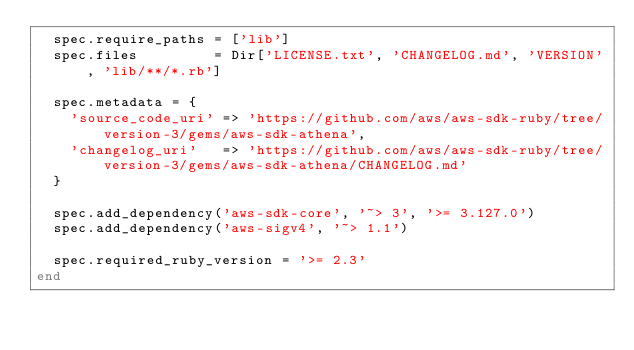<code> <loc_0><loc_0><loc_500><loc_500><_Ruby_>  spec.require_paths = ['lib']
  spec.files         = Dir['LICENSE.txt', 'CHANGELOG.md', 'VERSION', 'lib/**/*.rb']

  spec.metadata = {
    'source_code_uri' => 'https://github.com/aws/aws-sdk-ruby/tree/version-3/gems/aws-sdk-athena',
    'changelog_uri'   => 'https://github.com/aws/aws-sdk-ruby/tree/version-3/gems/aws-sdk-athena/CHANGELOG.md'
  }

  spec.add_dependency('aws-sdk-core', '~> 3', '>= 3.127.0')
  spec.add_dependency('aws-sigv4', '~> 1.1')

  spec.required_ruby_version = '>= 2.3'
end
</code> 